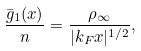<formula> <loc_0><loc_0><loc_500><loc_500>\frac { \bar { g } _ { 1 } ( x ) } { n } = \frac { \rho _ { \infty } } { | k _ { F } x | ^ { 1 / 2 } } ,</formula> 